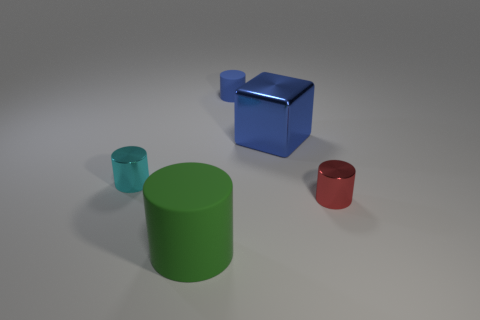Add 3 large metallic objects. How many objects exist? 8 Subtract all blue cylinders. How many cylinders are left? 3 Subtract all blocks. How many objects are left? 4 Subtract all cyan cylinders. How many cylinders are left? 3 Subtract 3 cylinders. How many cylinders are left? 1 Subtract all small gray metal things. Subtract all big matte cylinders. How many objects are left? 4 Add 1 small cylinders. How many small cylinders are left? 4 Add 1 gray matte objects. How many gray matte objects exist? 1 Subtract 0 yellow cubes. How many objects are left? 5 Subtract all green blocks. Subtract all purple balls. How many blocks are left? 1 